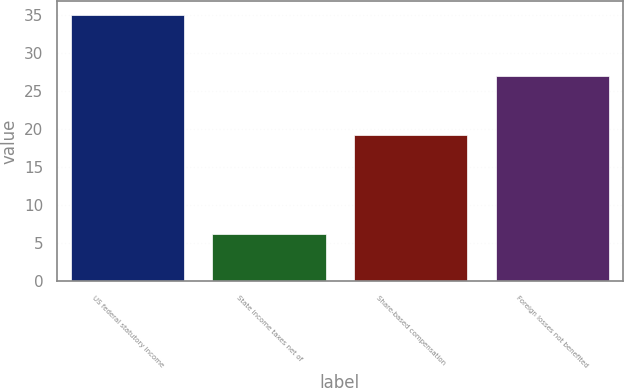Convert chart to OTSL. <chart><loc_0><loc_0><loc_500><loc_500><bar_chart><fcel>US federal statutory income<fcel>State income taxes net of<fcel>Share-based compensation<fcel>Foreign losses not benefited<nl><fcel>35<fcel>6.2<fcel>19.2<fcel>26.9<nl></chart> 